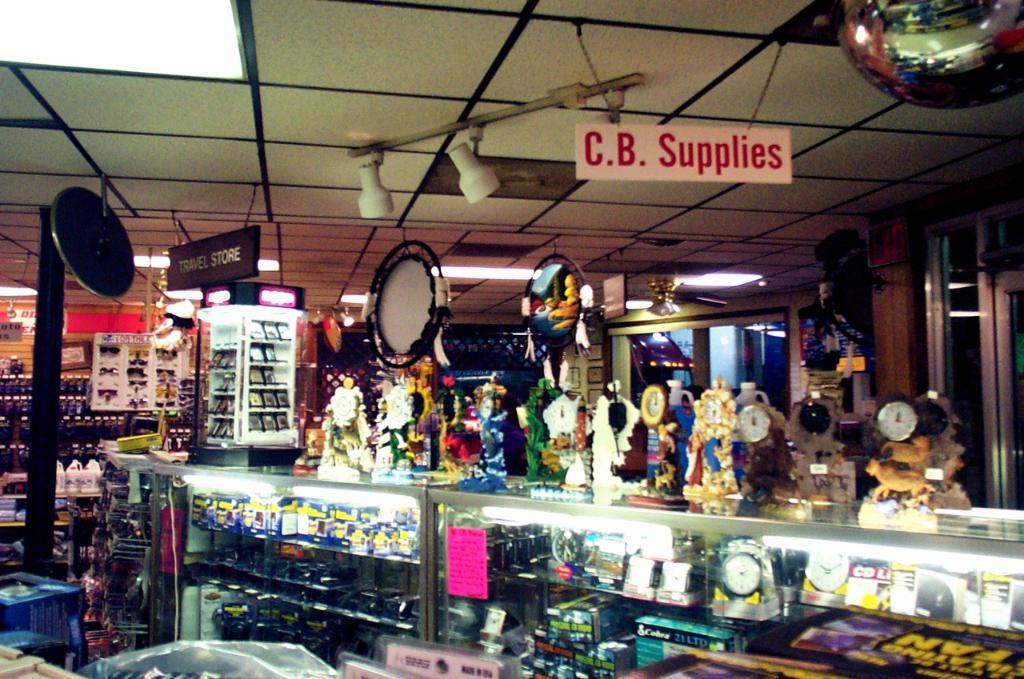<image>
Render a clear and concise summary of the photo. Store that is selling different antiques from the brand or company C.B. Supplies. 